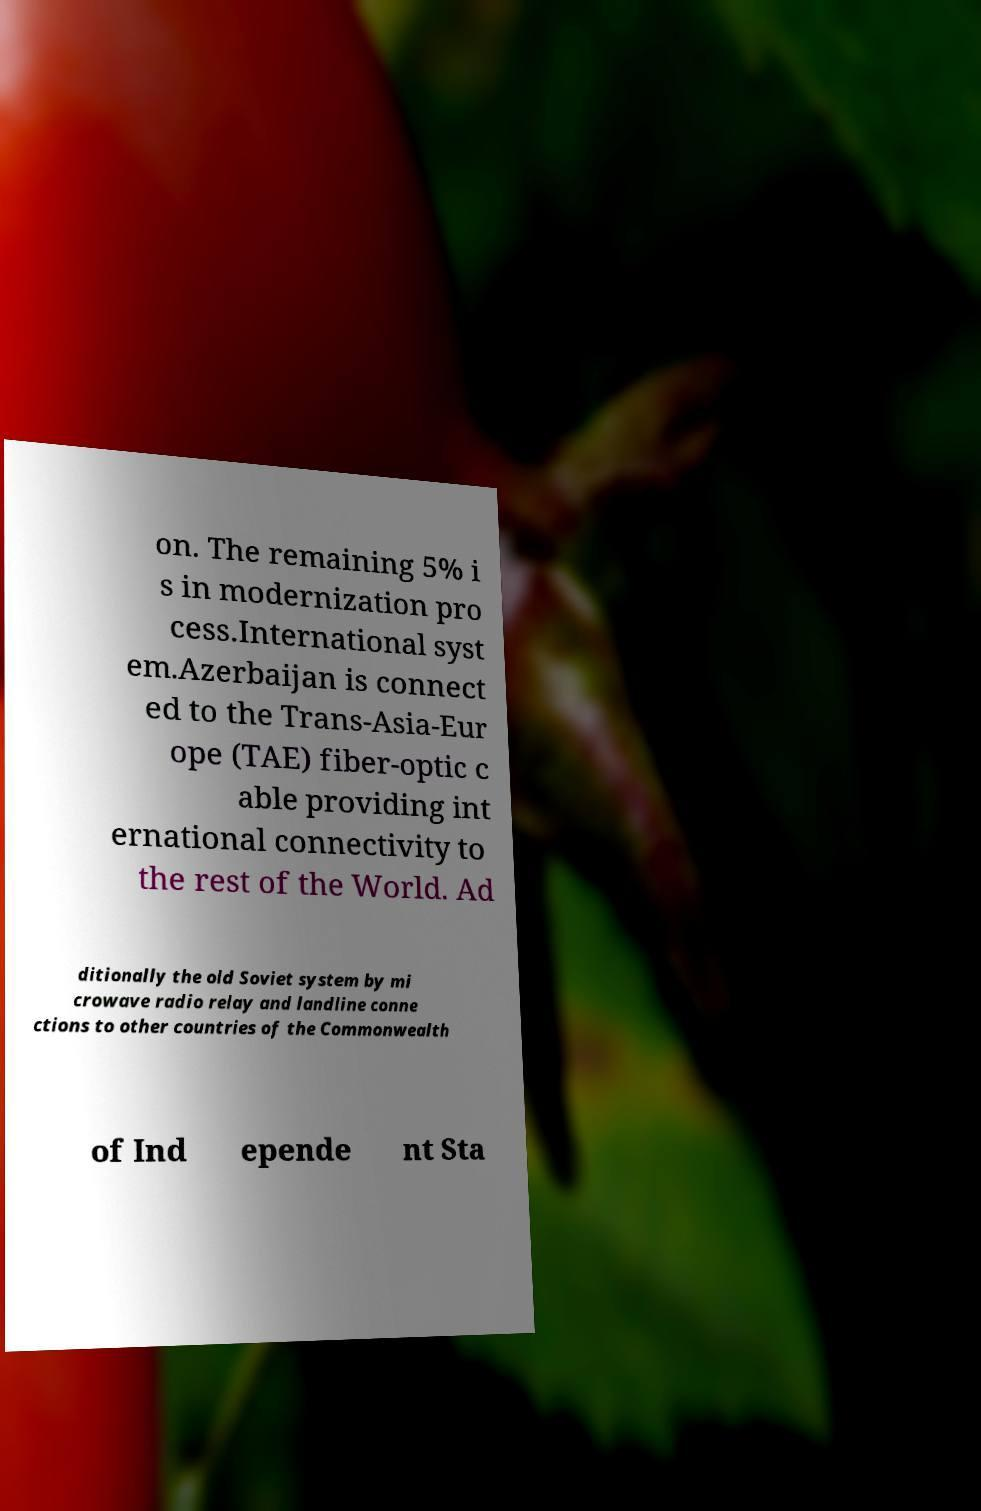What messages or text are displayed in this image? I need them in a readable, typed format. on. The remaining 5% i s in modernization pro cess.International syst em.Azerbaijan is connect ed to the Trans-Asia-Eur ope (TAE) fiber-optic c able providing int ernational connectivity to the rest of the World. Ad ditionally the old Soviet system by mi crowave radio relay and landline conne ctions to other countries of the Commonwealth of Ind epende nt Sta 